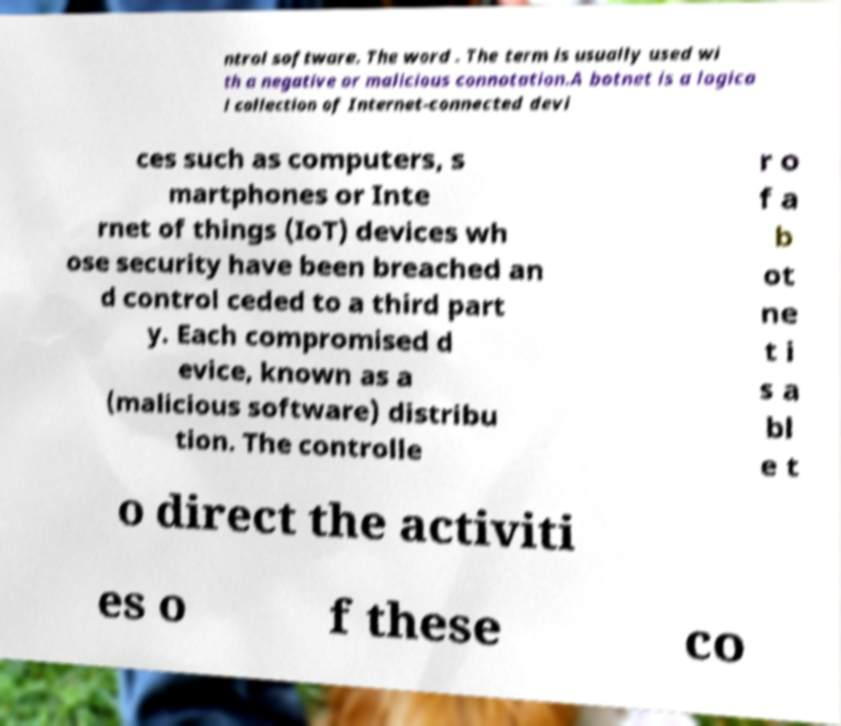Please identify and transcribe the text found in this image. ntrol software. The word . The term is usually used wi th a negative or malicious connotation.A botnet is a logica l collection of Internet-connected devi ces such as computers, s martphones or Inte rnet of things (IoT) devices wh ose security have been breached an d control ceded to a third part y. Each compromised d evice, known as a (malicious software) distribu tion. The controlle r o f a b ot ne t i s a bl e t o direct the activiti es o f these co 